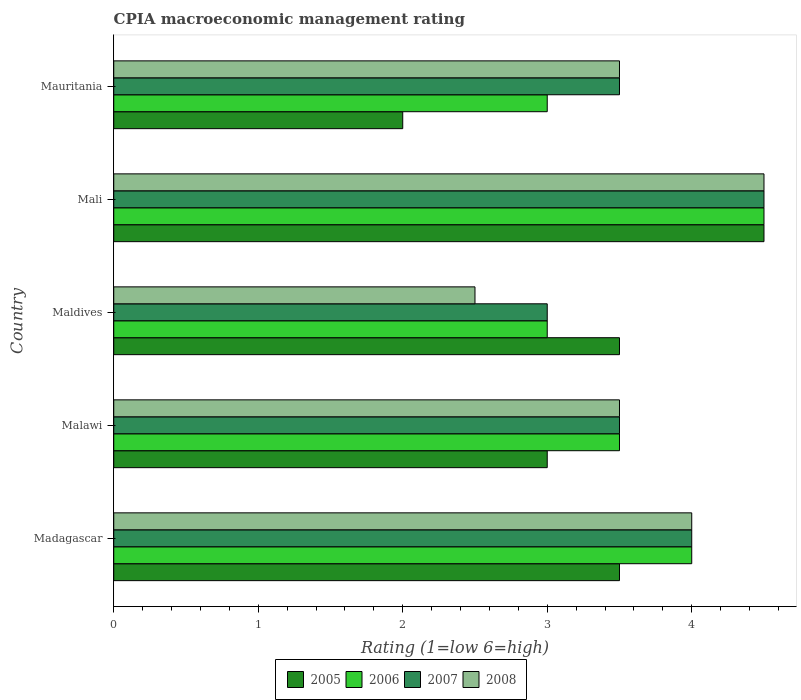How many bars are there on the 3rd tick from the bottom?
Your response must be concise. 4. What is the label of the 4th group of bars from the top?
Provide a short and direct response. Malawi. In how many cases, is the number of bars for a given country not equal to the number of legend labels?
Offer a very short reply. 0. In which country was the CPIA rating in 2005 maximum?
Your answer should be very brief. Mali. In which country was the CPIA rating in 2008 minimum?
Make the answer very short. Maldives. What is the difference between the CPIA rating in 2007 and CPIA rating in 2006 in Maldives?
Give a very brief answer. 0. In how many countries, is the CPIA rating in 2007 greater than 1.4 ?
Your answer should be very brief. 5. What is the ratio of the CPIA rating in 2005 in Madagascar to that in Mali?
Offer a very short reply. 0.78. Is the CPIA rating in 2008 in Madagascar less than that in Mauritania?
Offer a terse response. No. What is the difference between the highest and the lowest CPIA rating in 2005?
Make the answer very short. 2.5. What is the difference between two consecutive major ticks on the X-axis?
Provide a succinct answer. 1. Are the values on the major ticks of X-axis written in scientific E-notation?
Your answer should be very brief. No. Where does the legend appear in the graph?
Keep it short and to the point. Bottom center. How many legend labels are there?
Ensure brevity in your answer.  4. What is the title of the graph?
Your response must be concise. CPIA macroeconomic management rating. What is the Rating (1=low 6=high) of 2008 in Madagascar?
Keep it short and to the point. 4. What is the Rating (1=low 6=high) in 2006 in Malawi?
Your answer should be very brief. 3.5. What is the Rating (1=low 6=high) of 2006 in Mali?
Provide a short and direct response. 4.5. What is the Rating (1=low 6=high) in 2007 in Mali?
Your answer should be very brief. 4.5. Across all countries, what is the maximum Rating (1=low 6=high) in 2005?
Ensure brevity in your answer.  4.5. Across all countries, what is the maximum Rating (1=low 6=high) in 2006?
Your response must be concise. 4.5. Across all countries, what is the minimum Rating (1=low 6=high) of 2005?
Provide a succinct answer. 2. Across all countries, what is the minimum Rating (1=low 6=high) in 2006?
Keep it short and to the point. 3. What is the total Rating (1=low 6=high) in 2006 in the graph?
Offer a terse response. 18. What is the total Rating (1=low 6=high) in 2008 in the graph?
Your answer should be very brief. 18. What is the difference between the Rating (1=low 6=high) of 2005 in Madagascar and that in Malawi?
Offer a very short reply. 0.5. What is the difference between the Rating (1=low 6=high) in 2006 in Madagascar and that in Malawi?
Make the answer very short. 0.5. What is the difference between the Rating (1=low 6=high) of 2005 in Madagascar and that in Maldives?
Ensure brevity in your answer.  0. What is the difference between the Rating (1=low 6=high) in 2006 in Madagascar and that in Maldives?
Make the answer very short. 1. What is the difference between the Rating (1=low 6=high) in 2006 in Madagascar and that in Mali?
Offer a terse response. -0.5. What is the difference between the Rating (1=low 6=high) in 2007 in Madagascar and that in Mali?
Your response must be concise. -0.5. What is the difference between the Rating (1=low 6=high) of 2008 in Madagascar and that in Mali?
Give a very brief answer. -0.5. What is the difference between the Rating (1=low 6=high) of 2006 in Madagascar and that in Mauritania?
Provide a short and direct response. 1. What is the difference between the Rating (1=low 6=high) in 2007 in Madagascar and that in Mauritania?
Provide a short and direct response. 0.5. What is the difference between the Rating (1=low 6=high) in 2008 in Malawi and that in Maldives?
Make the answer very short. 1. What is the difference between the Rating (1=low 6=high) of 2005 in Malawi and that in Mali?
Offer a terse response. -1.5. What is the difference between the Rating (1=low 6=high) in 2008 in Malawi and that in Mali?
Your response must be concise. -1. What is the difference between the Rating (1=low 6=high) of 2008 in Malawi and that in Mauritania?
Provide a succinct answer. 0. What is the difference between the Rating (1=low 6=high) of 2006 in Maldives and that in Mali?
Your response must be concise. -1.5. What is the difference between the Rating (1=low 6=high) in 2007 in Maldives and that in Mali?
Keep it short and to the point. -1.5. What is the difference between the Rating (1=low 6=high) of 2006 in Maldives and that in Mauritania?
Give a very brief answer. 0. What is the difference between the Rating (1=low 6=high) of 2007 in Maldives and that in Mauritania?
Give a very brief answer. -0.5. What is the difference between the Rating (1=low 6=high) of 2007 in Mali and that in Mauritania?
Offer a terse response. 1. What is the difference between the Rating (1=low 6=high) of 2005 in Madagascar and the Rating (1=low 6=high) of 2007 in Malawi?
Provide a short and direct response. 0. What is the difference between the Rating (1=low 6=high) in 2006 in Madagascar and the Rating (1=low 6=high) in 2007 in Malawi?
Ensure brevity in your answer.  0.5. What is the difference between the Rating (1=low 6=high) of 2007 in Madagascar and the Rating (1=low 6=high) of 2008 in Malawi?
Provide a succinct answer. 0.5. What is the difference between the Rating (1=low 6=high) in 2005 in Madagascar and the Rating (1=low 6=high) in 2006 in Maldives?
Provide a succinct answer. 0.5. What is the difference between the Rating (1=low 6=high) in 2005 in Madagascar and the Rating (1=low 6=high) in 2008 in Maldives?
Offer a very short reply. 1. What is the difference between the Rating (1=low 6=high) in 2006 in Madagascar and the Rating (1=low 6=high) in 2008 in Maldives?
Offer a terse response. 1.5. What is the difference between the Rating (1=low 6=high) of 2006 in Madagascar and the Rating (1=low 6=high) of 2008 in Mali?
Offer a terse response. -0.5. What is the difference between the Rating (1=low 6=high) of 2007 in Madagascar and the Rating (1=low 6=high) of 2008 in Mali?
Your answer should be compact. -0.5. What is the difference between the Rating (1=low 6=high) in 2005 in Madagascar and the Rating (1=low 6=high) in 2006 in Mauritania?
Your response must be concise. 0.5. What is the difference between the Rating (1=low 6=high) of 2006 in Madagascar and the Rating (1=low 6=high) of 2007 in Mauritania?
Keep it short and to the point. 0.5. What is the difference between the Rating (1=low 6=high) in 2006 in Madagascar and the Rating (1=low 6=high) in 2008 in Mauritania?
Your answer should be compact. 0.5. What is the difference between the Rating (1=low 6=high) of 2005 in Malawi and the Rating (1=low 6=high) of 2006 in Maldives?
Provide a succinct answer. 0. What is the difference between the Rating (1=low 6=high) of 2005 in Malawi and the Rating (1=low 6=high) of 2007 in Maldives?
Your answer should be compact. 0. What is the difference between the Rating (1=low 6=high) of 2005 in Malawi and the Rating (1=low 6=high) of 2008 in Maldives?
Provide a short and direct response. 0.5. What is the difference between the Rating (1=low 6=high) in 2006 in Malawi and the Rating (1=low 6=high) in 2007 in Maldives?
Offer a very short reply. 0.5. What is the difference between the Rating (1=low 6=high) in 2005 in Malawi and the Rating (1=low 6=high) in 2006 in Mali?
Your response must be concise. -1.5. What is the difference between the Rating (1=low 6=high) in 2005 in Malawi and the Rating (1=low 6=high) in 2008 in Mali?
Your answer should be very brief. -1.5. What is the difference between the Rating (1=low 6=high) in 2006 in Malawi and the Rating (1=low 6=high) in 2007 in Mali?
Provide a succinct answer. -1. What is the difference between the Rating (1=low 6=high) in 2006 in Malawi and the Rating (1=low 6=high) in 2008 in Mali?
Keep it short and to the point. -1. What is the difference between the Rating (1=low 6=high) in 2005 in Malawi and the Rating (1=low 6=high) in 2008 in Mauritania?
Offer a very short reply. -0.5. What is the difference between the Rating (1=low 6=high) of 2007 in Malawi and the Rating (1=low 6=high) of 2008 in Mauritania?
Your answer should be very brief. 0. What is the difference between the Rating (1=low 6=high) of 2005 in Maldives and the Rating (1=low 6=high) of 2006 in Mauritania?
Keep it short and to the point. 0.5. What is the difference between the Rating (1=low 6=high) of 2005 in Maldives and the Rating (1=low 6=high) of 2008 in Mauritania?
Give a very brief answer. 0. What is the difference between the Rating (1=low 6=high) in 2006 in Maldives and the Rating (1=low 6=high) in 2008 in Mauritania?
Provide a succinct answer. -0.5. What is the difference between the Rating (1=low 6=high) in 2005 in Mali and the Rating (1=low 6=high) in 2006 in Mauritania?
Keep it short and to the point. 1.5. What is the difference between the Rating (1=low 6=high) in 2005 in Mali and the Rating (1=low 6=high) in 2007 in Mauritania?
Provide a short and direct response. 1. What is the difference between the Rating (1=low 6=high) in 2005 in Mali and the Rating (1=low 6=high) in 2008 in Mauritania?
Your answer should be compact. 1. What is the difference between the Rating (1=low 6=high) in 2006 in Mali and the Rating (1=low 6=high) in 2007 in Mauritania?
Offer a terse response. 1. What is the difference between the Rating (1=low 6=high) of 2006 in Mali and the Rating (1=low 6=high) of 2008 in Mauritania?
Provide a succinct answer. 1. What is the average Rating (1=low 6=high) in 2007 per country?
Your response must be concise. 3.7. What is the average Rating (1=low 6=high) of 2008 per country?
Offer a very short reply. 3.6. What is the difference between the Rating (1=low 6=high) of 2005 and Rating (1=low 6=high) of 2006 in Madagascar?
Ensure brevity in your answer.  -0.5. What is the difference between the Rating (1=low 6=high) in 2006 and Rating (1=low 6=high) in 2007 in Madagascar?
Ensure brevity in your answer.  0. What is the difference between the Rating (1=low 6=high) in 2006 and Rating (1=low 6=high) in 2008 in Madagascar?
Your response must be concise. 0. What is the difference between the Rating (1=low 6=high) of 2005 and Rating (1=low 6=high) of 2006 in Malawi?
Give a very brief answer. -0.5. What is the difference between the Rating (1=low 6=high) of 2005 and Rating (1=low 6=high) of 2008 in Malawi?
Provide a short and direct response. -0.5. What is the difference between the Rating (1=low 6=high) in 2006 and Rating (1=low 6=high) in 2007 in Malawi?
Make the answer very short. 0. What is the difference between the Rating (1=low 6=high) in 2005 and Rating (1=low 6=high) in 2006 in Maldives?
Provide a short and direct response. 0.5. What is the difference between the Rating (1=low 6=high) in 2005 and Rating (1=low 6=high) in 2007 in Maldives?
Provide a succinct answer. 0.5. What is the difference between the Rating (1=low 6=high) in 2005 and Rating (1=low 6=high) in 2008 in Maldives?
Ensure brevity in your answer.  1. What is the difference between the Rating (1=low 6=high) of 2006 and Rating (1=low 6=high) of 2007 in Maldives?
Give a very brief answer. 0. What is the difference between the Rating (1=low 6=high) in 2006 and Rating (1=low 6=high) in 2008 in Maldives?
Give a very brief answer. 0.5. What is the difference between the Rating (1=low 6=high) in 2007 and Rating (1=low 6=high) in 2008 in Maldives?
Provide a succinct answer. 0.5. What is the difference between the Rating (1=low 6=high) in 2005 and Rating (1=low 6=high) in 2006 in Mali?
Your answer should be very brief. 0. What is the difference between the Rating (1=low 6=high) in 2007 and Rating (1=low 6=high) in 2008 in Mali?
Make the answer very short. 0. What is the difference between the Rating (1=low 6=high) of 2005 and Rating (1=low 6=high) of 2007 in Mauritania?
Your response must be concise. -1.5. What is the ratio of the Rating (1=low 6=high) of 2006 in Madagascar to that in Malawi?
Your response must be concise. 1.14. What is the ratio of the Rating (1=low 6=high) in 2008 in Madagascar to that in Malawi?
Your answer should be compact. 1.14. What is the ratio of the Rating (1=low 6=high) of 2005 in Madagascar to that in Maldives?
Your answer should be compact. 1. What is the ratio of the Rating (1=low 6=high) of 2006 in Madagascar to that in Maldives?
Give a very brief answer. 1.33. What is the ratio of the Rating (1=low 6=high) in 2008 in Madagascar to that in Maldives?
Provide a succinct answer. 1.6. What is the ratio of the Rating (1=low 6=high) in 2007 in Madagascar to that in Mali?
Your answer should be very brief. 0.89. What is the ratio of the Rating (1=low 6=high) in 2005 in Madagascar to that in Mauritania?
Provide a short and direct response. 1.75. What is the ratio of the Rating (1=low 6=high) in 2005 in Malawi to that in Maldives?
Your response must be concise. 0.86. What is the ratio of the Rating (1=low 6=high) in 2006 in Malawi to that in Maldives?
Your answer should be compact. 1.17. What is the ratio of the Rating (1=low 6=high) in 2007 in Malawi to that in Maldives?
Your response must be concise. 1.17. What is the ratio of the Rating (1=low 6=high) of 2008 in Malawi to that in Maldives?
Provide a short and direct response. 1.4. What is the ratio of the Rating (1=low 6=high) in 2005 in Malawi to that in Mali?
Keep it short and to the point. 0.67. What is the ratio of the Rating (1=low 6=high) in 2007 in Malawi to that in Mali?
Provide a short and direct response. 0.78. What is the ratio of the Rating (1=low 6=high) of 2008 in Malawi to that in Mali?
Provide a short and direct response. 0.78. What is the ratio of the Rating (1=low 6=high) in 2007 in Malawi to that in Mauritania?
Provide a short and direct response. 1. What is the ratio of the Rating (1=low 6=high) in 2005 in Maldives to that in Mali?
Make the answer very short. 0.78. What is the ratio of the Rating (1=low 6=high) in 2006 in Maldives to that in Mali?
Your answer should be compact. 0.67. What is the ratio of the Rating (1=low 6=high) of 2007 in Maldives to that in Mali?
Offer a very short reply. 0.67. What is the ratio of the Rating (1=low 6=high) of 2008 in Maldives to that in Mali?
Offer a terse response. 0.56. What is the ratio of the Rating (1=low 6=high) of 2005 in Maldives to that in Mauritania?
Ensure brevity in your answer.  1.75. What is the ratio of the Rating (1=low 6=high) of 2006 in Maldives to that in Mauritania?
Make the answer very short. 1. What is the ratio of the Rating (1=low 6=high) of 2005 in Mali to that in Mauritania?
Your response must be concise. 2.25. What is the ratio of the Rating (1=low 6=high) in 2007 in Mali to that in Mauritania?
Provide a succinct answer. 1.29. What is the ratio of the Rating (1=low 6=high) of 2008 in Mali to that in Mauritania?
Your answer should be compact. 1.29. What is the difference between the highest and the second highest Rating (1=low 6=high) in 2007?
Ensure brevity in your answer.  0.5. What is the difference between the highest and the lowest Rating (1=low 6=high) of 2005?
Make the answer very short. 2.5. What is the difference between the highest and the lowest Rating (1=low 6=high) in 2008?
Your answer should be compact. 2. 